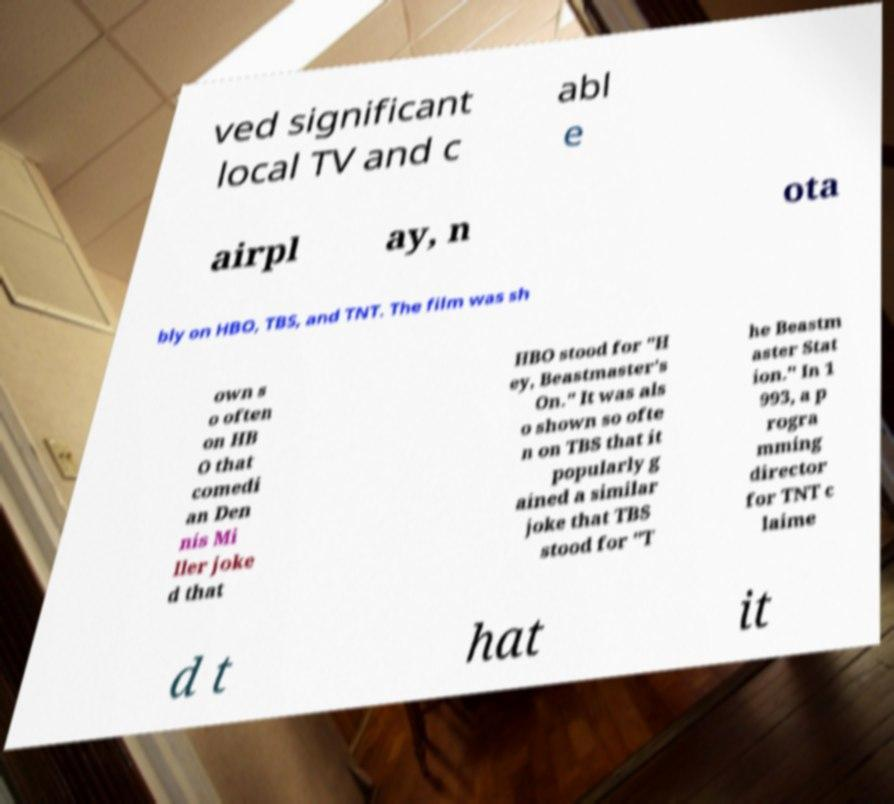For documentation purposes, I need the text within this image transcribed. Could you provide that? ved significant local TV and c abl e airpl ay, n ota bly on HBO, TBS, and TNT. The film was sh own s o often on HB O that comedi an Den nis Mi ller joke d that HBO stood for "H ey, Beastmaster's On." It was als o shown so ofte n on TBS that it popularly g ained a similar joke that TBS stood for "T he Beastm aster Stat ion." In 1 993, a p rogra mming director for TNT c laime d t hat it 